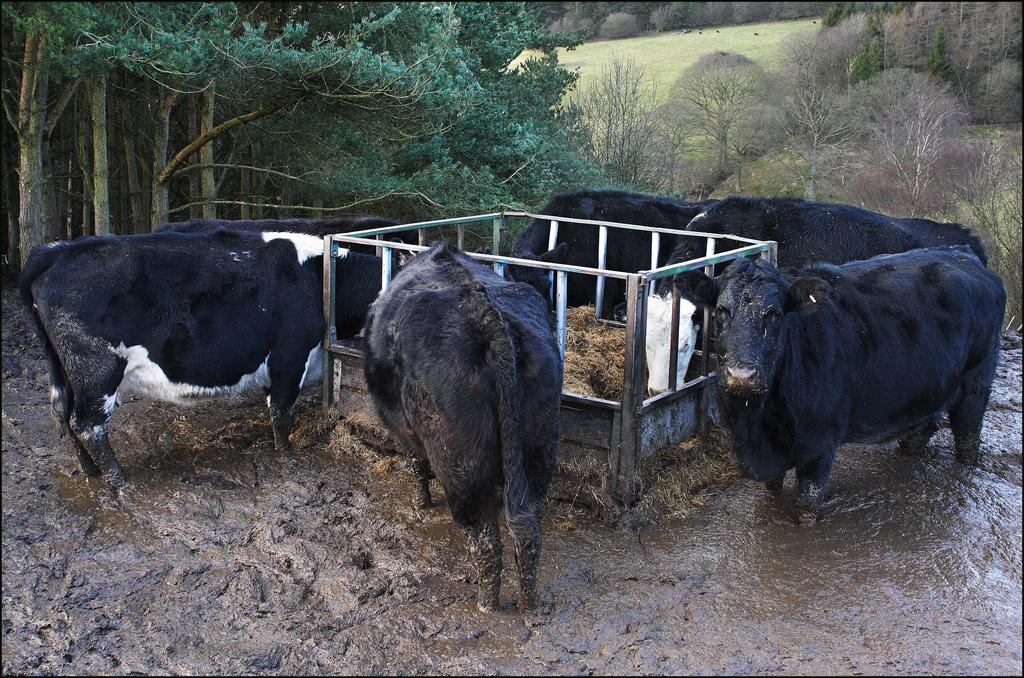What are the animals doing in the image? The animals are standing in mud in the image. What object is present in the image that is related to feeding the animals? There is a metal feed grass trough in the image. What can be seen in the background of the image? There are trees in the background of the image. What type of river can be seen flowing through the image? There is no river present in the image; it features animals standing in mud with a metal feed grass trough and trees in the background. 